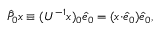Convert formula to latex. <formula><loc_0><loc_0><loc_500><loc_500>\begin{array} { r } { \hat { P } _ { 0 } x \equiv ( U ^ { - 1 } x ) _ { 0 } \hat { e } _ { 0 } = ( x { \cdot } \hat { e } _ { 0 } ) \hat { e } _ { 0 } , } \end{array}</formula> 